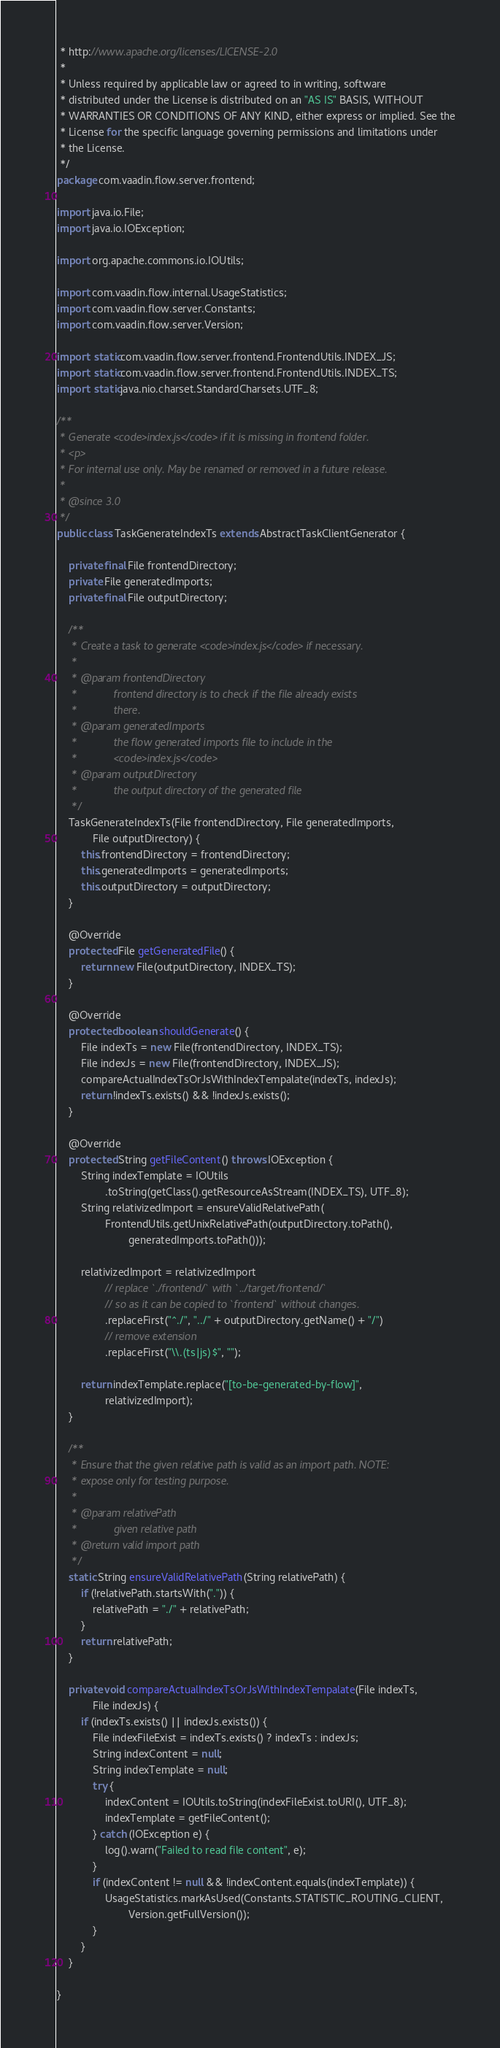Convert code to text. <code><loc_0><loc_0><loc_500><loc_500><_Java_> * http://www.apache.org/licenses/LICENSE-2.0
 *
 * Unless required by applicable law or agreed to in writing, software
 * distributed under the License is distributed on an "AS IS" BASIS, WITHOUT
 * WARRANTIES OR CONDITIONS OF ANY KIND, either express or implied. See the
 * License for the specific language governing permissions and limitations under
 * the License.
 */
package com.vaadin.flow.server.frontend;

import java.io.File;
import java.io.IOException;

import org.apache.commons.io.IOUtils;

import com.vaadin.flow.internal.UsageStatistics;
import com.vaadin.flow.server.Constants;
import com.vaadin.flow.server.Version;

import static com.vaadin.flow.server.frontend.FrontendUtils.INDEX_JS;
import static com.vaadin.flow.server.frontend.FrontendUtils.INDEX_TS;
import static java.nio.charset.StandardCharsets.UTF_8;

/**
 * Generate <code>index.js</code> if it is missing in frontend folder.
 * <p>
 * For internal use only. May be renamed or removed in a future release.
 *
 * @since 3.0
 */
public class TaskGenerateIndexTs extends AbstractTaskClientGenerator {

    private final File frontendDirectory;
    private File generatedImports;
    private final File outputDirectory;

    /**
     * Create a task to generate <code>index.js</code> if necessary.
     *
     * @param frontendDirectory
     *            frontend directory is to check if the file already exists
     *            there.
     * @param generatedImports
     *            the flow generated imports file to include in the
     *            <code>index.js</code>
     * @param outputDirectory
     *            the output directory of the generated file
     */
    TaskGenerateIndexTs(File frontendDirectory, File generatedImports,
            File outputDirectory) {
        this.frontendDirectory = frontendDirectory;
        this.generatedImports = generatedImports;
        this.outputDirectory = outputDirectory;
    }

    @Override
    protected File getGeneratedFile() {
        return new File(outputDirectory, INDEX_TS);
    }

    @Override
    protected boolean shouldGenerate() {
        File indexTs = new File(frontendDirectory, INDEX_TS);
        File indexJs = new File(frontendDirectory, INDEX_JS);
        compareActualIndexTsOrJsWithIndexTempalate(indexTs, indexJs);
        return !indexTs.exists() && !indexJs.exists();
    }

    @Override
    protected String getFileContent() throws IOException {
        String indexTemplate = IOUtils
                .toString(getClass().getResourceAsStream(INDEX_TS), UTF_8);
        String relativizedImport = ensureValidRelativePath(
                FrontendUtils.getUnixRelativePath(outputDirectory.toPath(),
                        generatedImports.toPath()));

        relativizedImport = relativizedImport
                // replace `./frontend/` with `../target/frontend/`
                // so as it can be copied to `frontend` without changes.
                .replaceFirst("^./", "../" + outputDirectory.getName() + "/")
                // remove extension
                .replaceFirst("\\.(ts|js)$", "");

        return indexTemplate.replace("[to-be-generated-by-flow]",
                relativizedImport);
    }

    /**
     * Ensure that the given relative path is valid as an import path. NOTE:
     * expose only for testing purpose.
     *
     * @param relativePath
     *            given relative path
     * @return valid import path
     */
    static String ensureValidRelativePath(String relativePath) {
        if (!relativePath.startsWith(".")) {
            relativePath = "./" + relativePath;
        }
        return relativePath;
    }

    private void compareActualIndexTsOrJsWithIndexTempalate(File indexTs,
            File indexJs) {
        if (indexTs.exists() || indexJs.exists()) {
            File indexFileExist = indexTs.exists() ? indexTs : indexJs;
            String indexContent = null;
            String indexTemplate = null;
            try {
                indexContent = IOUtils.toString(indexFileExist.toURI(), UTF_8);
                indexTemplate = getFileContent();
            } catch (IOException e) {
                log().warn("Failed to read file content", e);
            }
            if (indexContent != null && !indexContent.equals(indexTemplate)) {
                UsageStatistics.markAsUsed(Constants.STATISTIC_ROUTING_CLIENT,
                        Version.getFullVersion());
            }
        }
    }

}
</code> 